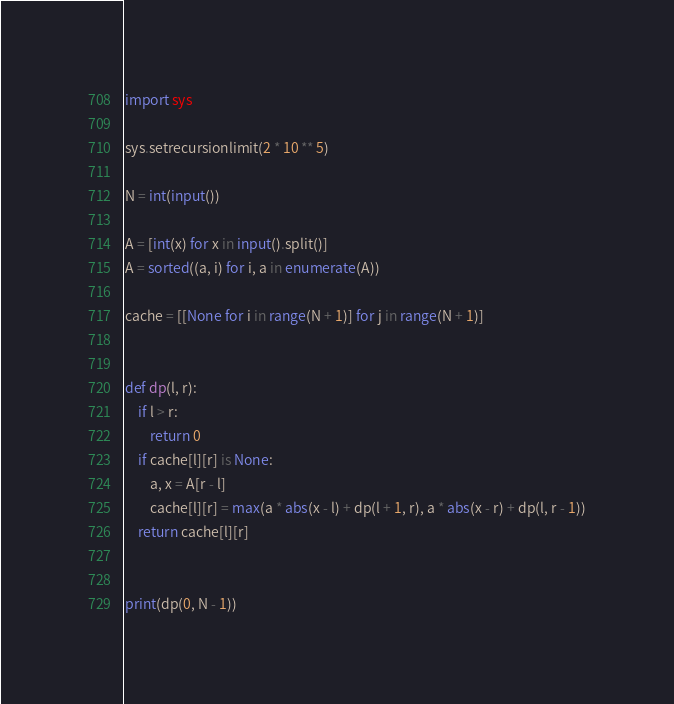<code> <loc_0><loc_0><loc_500><loc_500><_Python_>import sys

sys.setrecursionlimit(2 * 10 ** 5)

N = int(input())

A = [int(x) for x in input().split()]
A = sorted((a, i) for i, a in enumerate(A))

cache = [[None for i in range(N + 1)] for j in range(N + 1)]


def dp(l, r):
    if l > r:
        return 0
    if cache[l][r] is None:
        a, x = A[r - l]
        cache[l][r] = max(a * abs(x - l) + dp(l + 1, r), a * abs(x - r) + dp(l, r - 1))
    return cache[l][r]


print(dp(0, N - 1))
</code> 